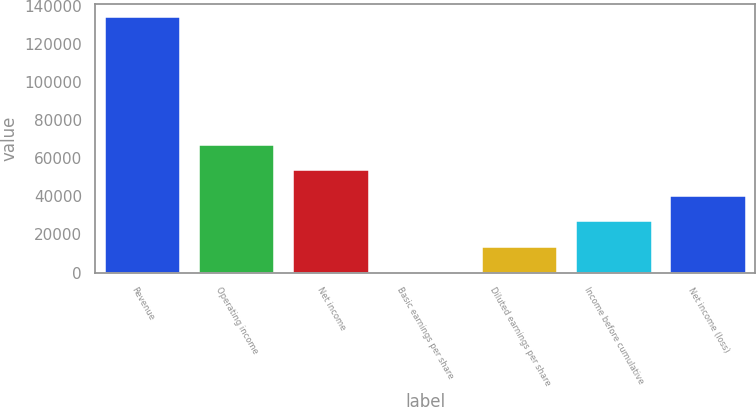<chart> <loc_0><loc_0><loc_500><loc_500><bar_chart><fcel>Revenue<fcel>Operating income<fcel>Net income<fcel>Basic earnings per share<fcel>Diluted earnings per share<fcel>Income before cumulative<fcel>Net income (loss)<nl><fcel>134322<fcel>67161.2<fcel>53729<fcel>0.34<fcel>13432.5<fcel>26864.7<fcel>40296.8<nl></chart> 